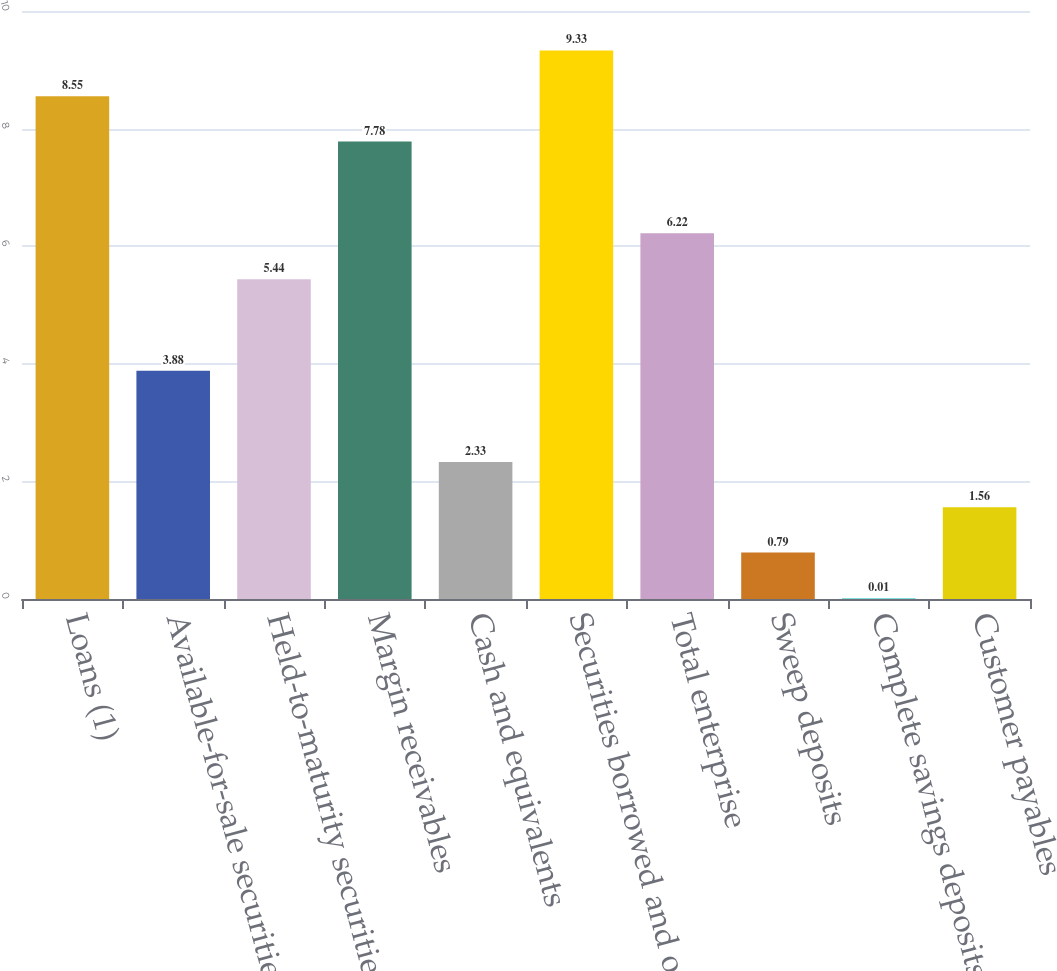Convert chart to OTSL. <chart><loc_0><loc_0><loc_500><loc_500><bar_chart><fcel>Loans (1)<fcel>Available-for-sale securities<fcel>Held-to-maturity securities<fcel>Margin receivables<fcel>Cash and equivalents<fcel>Securities borrowed and other<fcel>Total enterprise<fcel>Sweep deposits<fcel>Complete savings deposits<fcel>Customer payables<nl><fcel>8.55<fcel>3.88<fcel>5.44<fcel>7.78<fcel>2.33<fcel>9.33<fcel>6.22<fcel>0.79<fcel>0.01<fcel>1.56<nl></chart> 